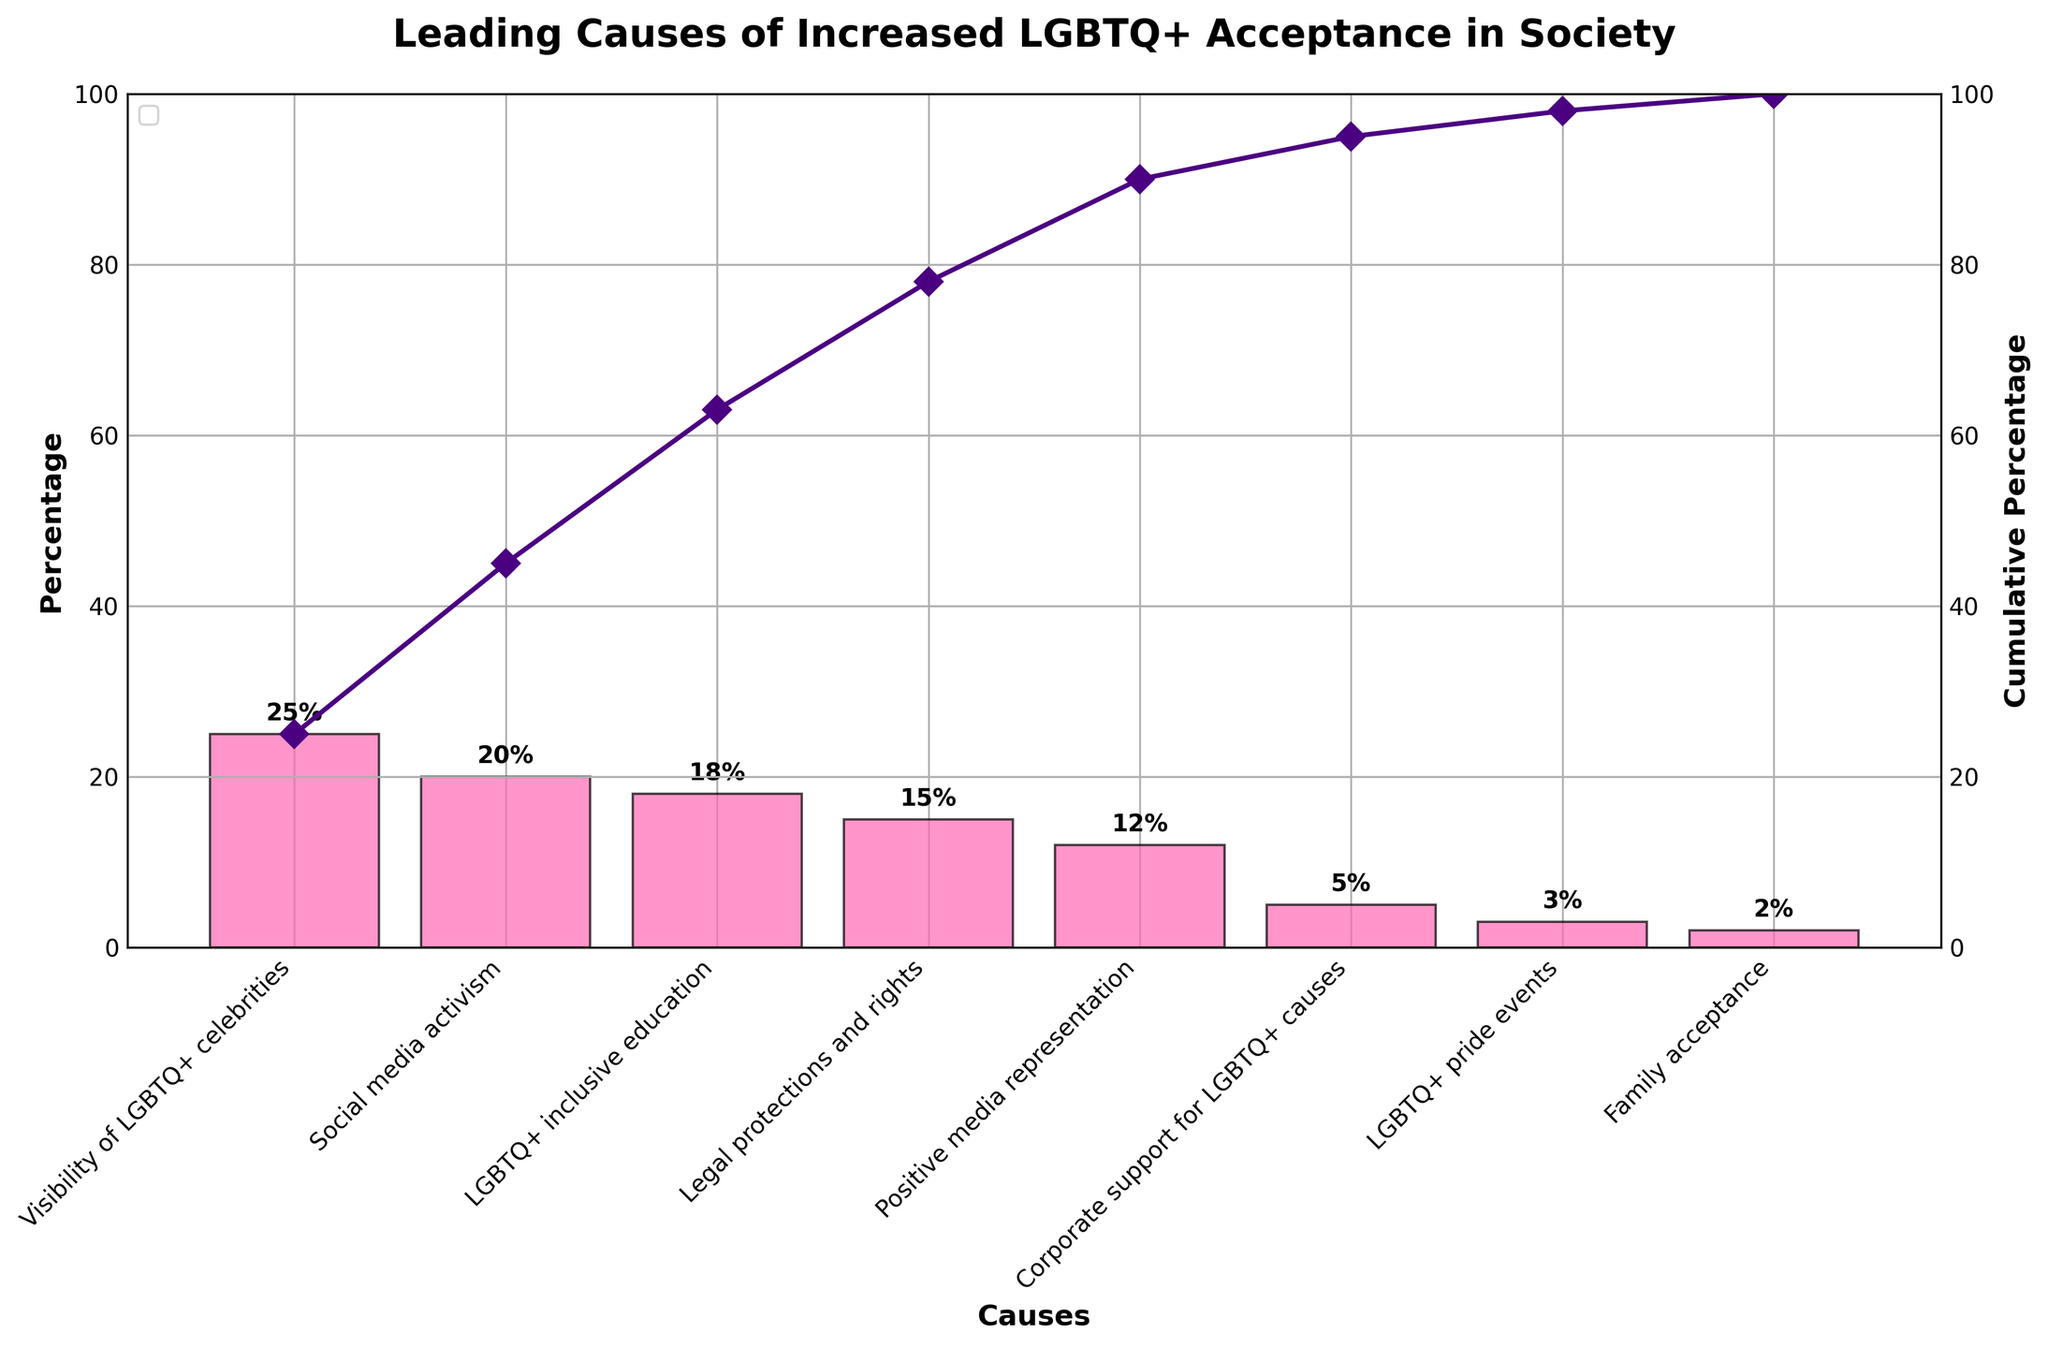what is the title of the chart? The title is prominently displayed at the top of the chart. It gives an overview of the subject matter covered by the chart.
Answer: Leading Causes of Increased LGBTQ+ Acceptance in Society What is the percentage impact of the Visibility of LGBTQ+ celebrities? Read the data point for "Visibility of LGBTQ+ celebrities" on the chart. It is the first bar in the chart and also labeled with its value.
Answer: 25% Which cause has the least impact on increasing LGBTQ+ acceptance according to the chart? The last bar in the chart with the smallest percentage value represents the cause with the least impact.
Answer: Family acceptance What is the cumulative percentage after including Legal protections and rights? To find this, look at the cumulative line and the label for the cause "Legal protections and rights". Sum the values up to this point: 25 (Visibility of LGBTQ+ celebrities) + 20 (Social media activism) + 18 (LGBTQ+ inclusive education) + 15 (Legal protections and rights), which equals 78.
Answer: 78% How do Social media activism and Positive media representation compare in terms of impact? Identify the heights of the bars for both "Social media activism" and "Positive media representation". "Social media activism" has a percentage of 20%, while "Positive media representation" has 12%.
Answer: Social media activism has a greater impact By how much does Corporate support for LGBTQ+ causes contribute less than LGBTQ+ inclusive education? Subtract the percentage of "Corporate support for LGBTQ+ causes" from "LGBTQ+ inclusive education". This is 18% - 5% which equals 13%.
Answer: 13% What are the first three causes with the highest impact? The top three causes can be identified by their ranking in the chart. The first three bars are "Visibility of LGBTQ+ celebrities" (25%), "Social media activism" (20%), and "LGBTQ+ inclusive education" (18%).
Answer: Visibility of LGBTQ+ celebrities, Social media activism, LGBTQ+ inclusive education What's the cumulative percentage up to the contribution of "Corporate support for LGBTQ+ causes"? Add the percentages of the bars up to "Corporate support for LGBTQ+ causes": 25 (Visibility of LGBTQ+ celebrities) + 20 (Social media activism) + 18 (LGBTQ+ inclusive education) + 15 (Legal protections and rights) + 12 (Positive media representation) + 5 (Corporate support for LGBTQ+ causes). This equals 95%.
Answer: 95% What percentage of the total impact does LGBTQ+ pride events contribute according to the chart? Look at the bar labeled "LGBTQ+ pride events" which indicates its exact value.
Answer: 3% What color is used for the bars on the chart? The bars are consistently colored, making it easy to recognize and interpret.
Answer: Pink 